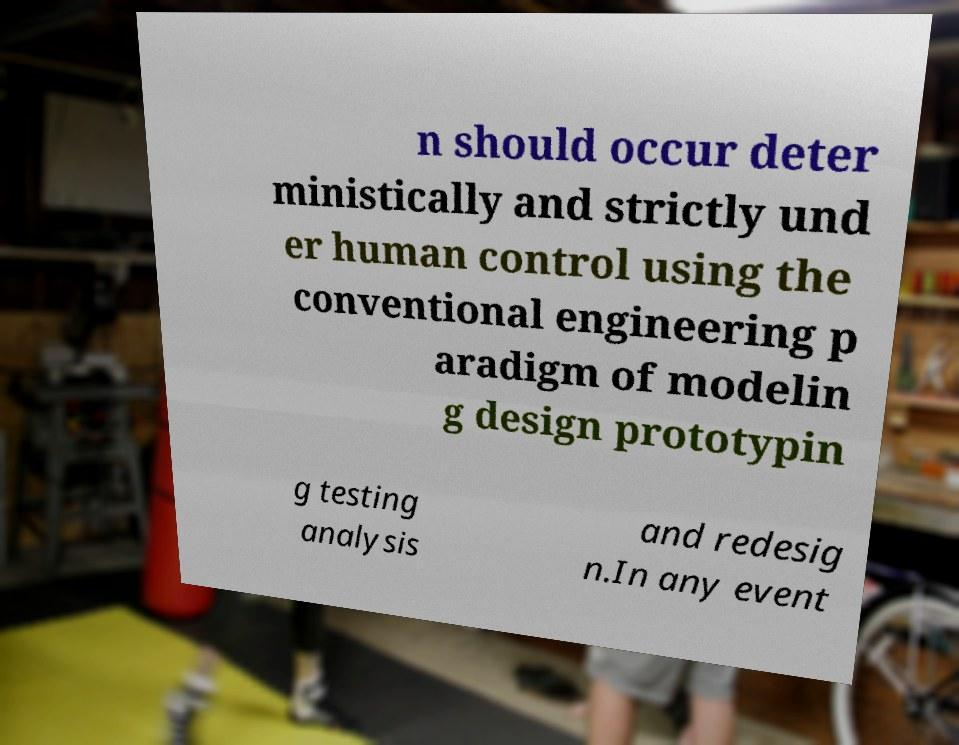Can you accurately transcribe the text from the provided image for me? n should occur deter ministically and strictly und er human control using the conventional engineering p aradigm of modelin g design prototypin g testing analysis and redesig n.In any event 